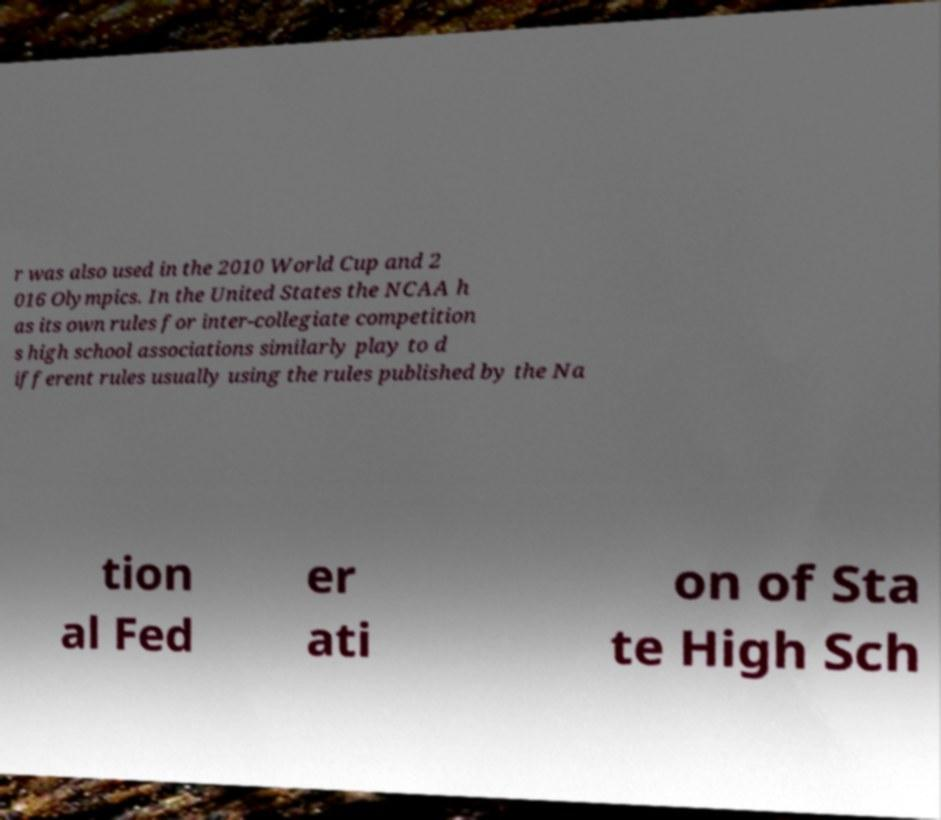For documentation purposes, I need the text within this image transcribed. Could you provide that? r was also used in the 2010 World Cup and 2 016 Olympics. In the United States the NCAA h as its own rules for inter-collegiate competition s high school associations similarly play to d ifferent rules usually using the rules published by the Na tion al Fed er ati on of Sta te High Sch 